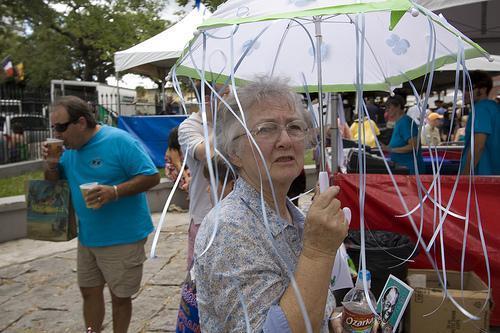How many people have gray hair?
Give a very brief answer. 1. How many people are in blue?
Give a very brief answer. 3. How many glass in the mens hand?
Give a very brief answer. 2. 